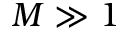<formula> <loc_0><loc_0><loc_500><loc_500>M \gg 1</formula> 